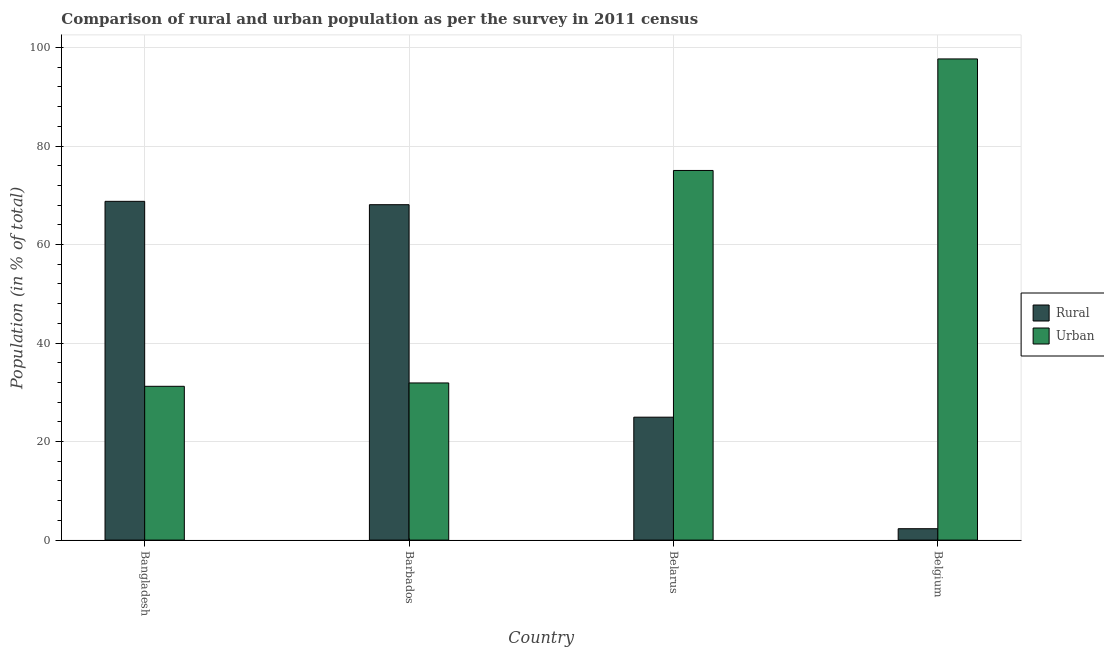How many different coloured bars are there?
Provide a short and direct response. 2. Are the number of bars per tick equal to the number of legend labels?
Provide a succinct answer. Yes. How many bars are there on the 2nd tick from the right?
Give a very brief answer. 2. What is the label of the 1st group of bars from the left?
Offer a terse response. Bangladesh. In how many cases, is the number of bars for a given country not equal to the number of legend labels?
Give a very brief answer. 0. What is the urban population in Bangladesh?
Keep it short and to the point. 31.23. Across all countries, what is the maximum urban population?
Provide a short and direct response. 97.69. Across all countries, what is the minimum urban population?
Ensure brevity in your answer.  31.23. What is the total rural population in the graph?
Give a very brief answer. 164.14. What is the difference between the rural population in Bangladesh and that in Barbados?
Your answer should be compact. 0.68. What is the difference between the urban population in Belarus and the rural population in Barbados?
Your answer should be very brief. 6.95. What is the average urban population per country?
Give a very brief answer. 58.97. What is the difference between the rural population and urban population in Bangladesh?
Your answer should be compact. 37.55. What is the ratio of the rural population in Bangladesh to that in Belarus?
Your response must be concise. 2.76. Is the urban population in Barbados less than that in Belgium?
Make the answer very short. Yes. What is the difference between the highest and the second highest urban population?
Offer a terse response. 22.64. What is the difference between the highest and the lowest urban population?
Provide a succinct answer. 66.46. In how many countries, is the rural population greater than the average rural population taken over all countries?
Your answer should be very brief. 2. What does the 2nd bar from the left in Belarus represents?
Make the answer very short. Urban. What does the 2nd bar from the right in Belarus represents?
Make the answer very short. Rural. How many bars are there?
Make the answer very short. 8. Are all the bars in the graph horizontal?
Give a very brief answer. No. Does the graph contain any zero values?
Make the answer very short. No. How many legend labels are there?
Provide a short and direct response. 2. How are the legend labels stacked?
Give a very brief answer. Vertical. What is the title of the graph?
Make the answer very short. Comparison of rural and urban population as per the survey in 2011 census. Does "Food" appear as one of the legend labels in the graph?
Your response must be concise. No. What is the label or title of the X-axis?
Ensure brevity in your answer.  Country. What is the label or title of the Y-axis?
Your response must be concise. Population (in % of total). What is the Population (in % of total) in Rural in Bangladesh?
Your answer should be very brief. 68.78. What is the Population (in % of total) in Urban in Bangladesh?
Your answer should be very brief. 31.23. What is the Population (in % of total) in Rural in Barbados?
Keep it short and to the point. 68.09. What is the Population (in % of total) in Urban in Barbados?
Provide a succinct answer. 31.91. What is the Population (in % of total) of Rural in Belarus?
Keep it short and to the point. 24.95. What is the Population (in % of total) in Urban in Belarus?
Your answer should be compact. 75.05. What is the Population (in % of total) in Rural in Belgium?
Ensure brevity in your answer.  2.31. What is the Population (in % of total) in Urban in Belgium?
Your answer should be compact. 97.69. Across all countries, what is the maximum Population (in % of total) of Rural?
Your answer should be compact. 68.78. Across all countries, what is the maximum Population (in % of total) in Urban?
Offer a terse response. 97.69. Across all countries, what is the minimum Population (in % of total) of Rural?
Keep it short and to the point. 2.31. Across all countries, what is the minimum Population (in % of total) in Urban?
Keep it short and to the point. 31.23. What is the total Population (in % of total) of Rural in the graph?
Provide a succinct answer. 164.14. What is the total Population (in % of total) in Urban in the graph?
Your answer should be very brief. 235.86. What is the difference between the Population (in % of total) in Rural in Bangladesh and that in Barbados?
Provide a succinct answer. 0.68. What is the difference between the Population (in % of total) in Urban in Bangladesh and that in Barbados?
Your answer should be compact. -0.68. What is the difference between the Population (in % of total) of Rural in Bangladesh and that in Belarus?
Offer a terse response. 43.82. What is the difference between the Population (in % of total) in Urban in Bangladesh and that in Belarus?
Offer a terse response. -43.82. What is the difference between the Population (in % of total) in Rural in Bangladesh and that in Belgium?
Your answer should be compact. 66.46. What is the difference between the Population (in % of total) in Urban in Bangladesh and that in Belgium?
Your answer should be compact. -66.46. What is the difference between the Population (in % of total) in Rural in Barbados and that in Belarus?
Offer a terse response. 43.14. What is the difference between the Population (in % of total) in Urban in Barbados and that in Belarus?
Ensure brevity in your answer.  -43.14. What is the difference between the Population (in % of total) in Rural in Barbados and that in Belgium?
Provide a short and direct response. 65.78. What is the difference between the Population (in % of total) of Urban in Barbados and that in Belgium?
Your response must be concise. -65.78. What is the difference between the Population (in % of total) of Rural in Belarus and that in Belgium?
Provide a short and direct response. 22.64. What is the difference between the Population (in % of total) of Urban in Belarus and that in Belgium?
Give a very brief answer. -22.64. What is the difference between the Population (in % of total) of Rural in Bangladesh and the Population (in % of total) of Urban in Barbados?
Provide a succinct answer. 36.87. What is the difference between the Population (in % of total) in Rural in Bangladesh and the Population (in % of total) in Urban in Belarus?
Give a very brief answer. -6.27. What is the difference between the Population (in % of total) in Rural in Bangladesh and the Population (in % of total) in Urban in Belgium?
Offer a terse response. -28.91. What is the difference between the Population (in % of total) of Rural in Barbados and the Population (in % of total) of Urban in Belarus?
Your answer should be very brief. -6.95. What is the difference between the Population (in % of total) in Rural in Barbados and the Population (in % of total) in Urban in Belgium?
Provide a succinct answer. -29.59. What is the difference between the Population (in % of total) in Rural in Belarus and the Population (in % of total) in Urban in Belgium?
Your answer should be very brief. -72.73. What is the average Population (in % of total) of Rural per country?
Offer a very short reply. 41.03. What is the average Population (in % of total) in Urban per country?
Your response must be concise. 58.97. What is the difference between the Population (in % of total) of Rural and Population (in % of total) of Urban in Bangladesh?
Keep it short and to the point. 37.55. What is the difference between the Population (in % of total) of Rural and Population (in % of total) of Urban in Barbados?
Offer a terse response. 36.19. What is the difference between the Population (in % of total) in Rural and Population (in % of total) in Urban in Belarus?
Ensure brevity in your answer.  -50.09. What is the difference between the Population (in % of total) of Rural and Population (in % of total) of Urban in Belgium?
Your answer should be very brief. -95.37. What is the ratio of the Population (in % of total) in Urban in Bangladesh to that in Barbados?
Ensure brevity in your answer.  0.98. What is the ratio of the Population (in % of total) in Rural in Bangladesh to that in Belarus?
Your answer should be very brief. 2.76. What is the ratio of the Population (in % of total) of Urban in Bangladesh to that in Belarus?
Provide a succinct answer. 0.42. What is the ratio of the Population (in % of total) of Rural in Bangladesh to that in Belgium?
Provide a short and direct response. 29.73. What is the ratio of the Population (in % of total) of Urban in Bangladesh to that in Belgium?
Your response must be concise. 0.32. What is the ratio of the Population (in % of total) of Rural in Barbados to that in Belarus?
Make the answer very short. 2.73. What is the ratio of the Population (in % of total) of Urban in Barbados to that in Belarus?
Make the answer very short. 0.43. What is the ratio of the Population (in % of total) of Rural in Barbados to that in Belgium?
Give a very brief answer. 29.44. What is the ratio of the Population (in % of total) in Urban in Barbados to that in Belgium?
Provide a succinct answer. 0.33. What is the ratio of the Population (in % of total) of Rural in Belarus to that in Belgium?
Your answer should be very brief. 10.79. What is the ratio of the Population (in % of total) of Urban in Belarus to that in Belgium?
Your response must be concise. 0.77. What is the difference between the highest and the second highest Population (in % of total) of Rural?
Your response must be concise. 0.68. What is the difference between the highest and the second highest Population (in % of total) in Urban?
Your answer should be very brief. 22.64. What is the difference between the highest and the lowest Population (in % of total) in Rural?
Offer a terse response. 66.46. What is the difference between the highest and the lowest Population (in % of total) in Urban?
Make the answer very short. 66.46. 